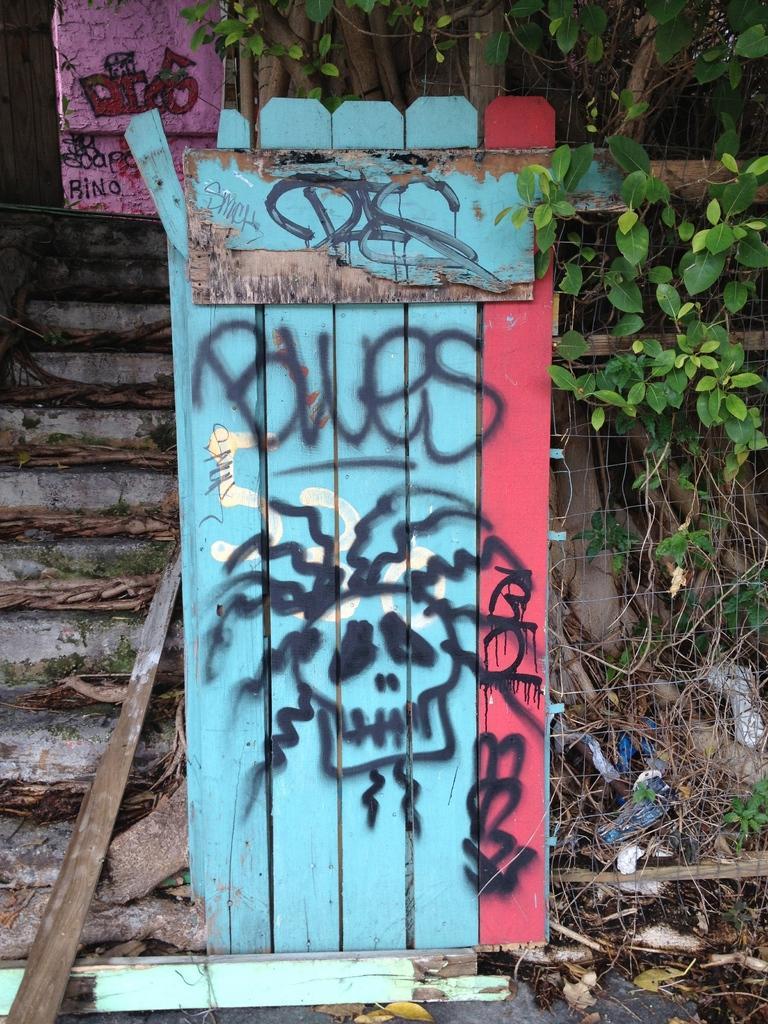How would you summarize this image in a sentence or two? In this picture I can see there is a wooden plank and there is something written on it and there are a few stairs at left side, there are few dry leaves, a plant at right side with a fence. 